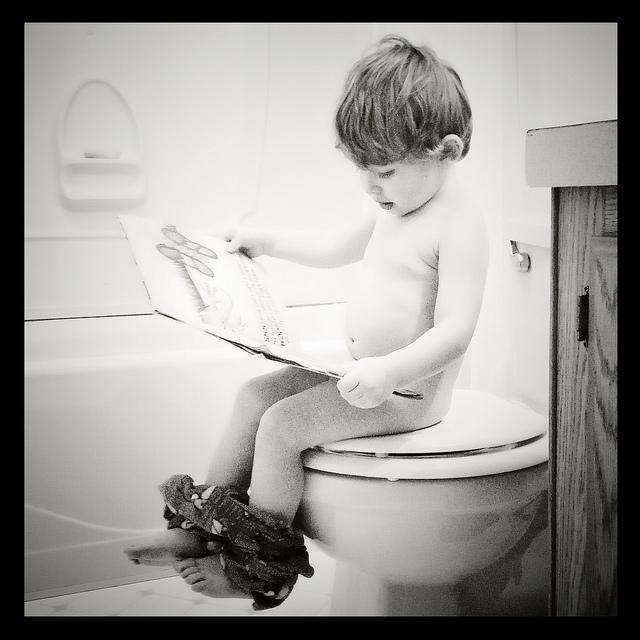How many people are in the picture?
Give a very brief answer. 1. How many horses are there?
Give a very brief answer. 0. 